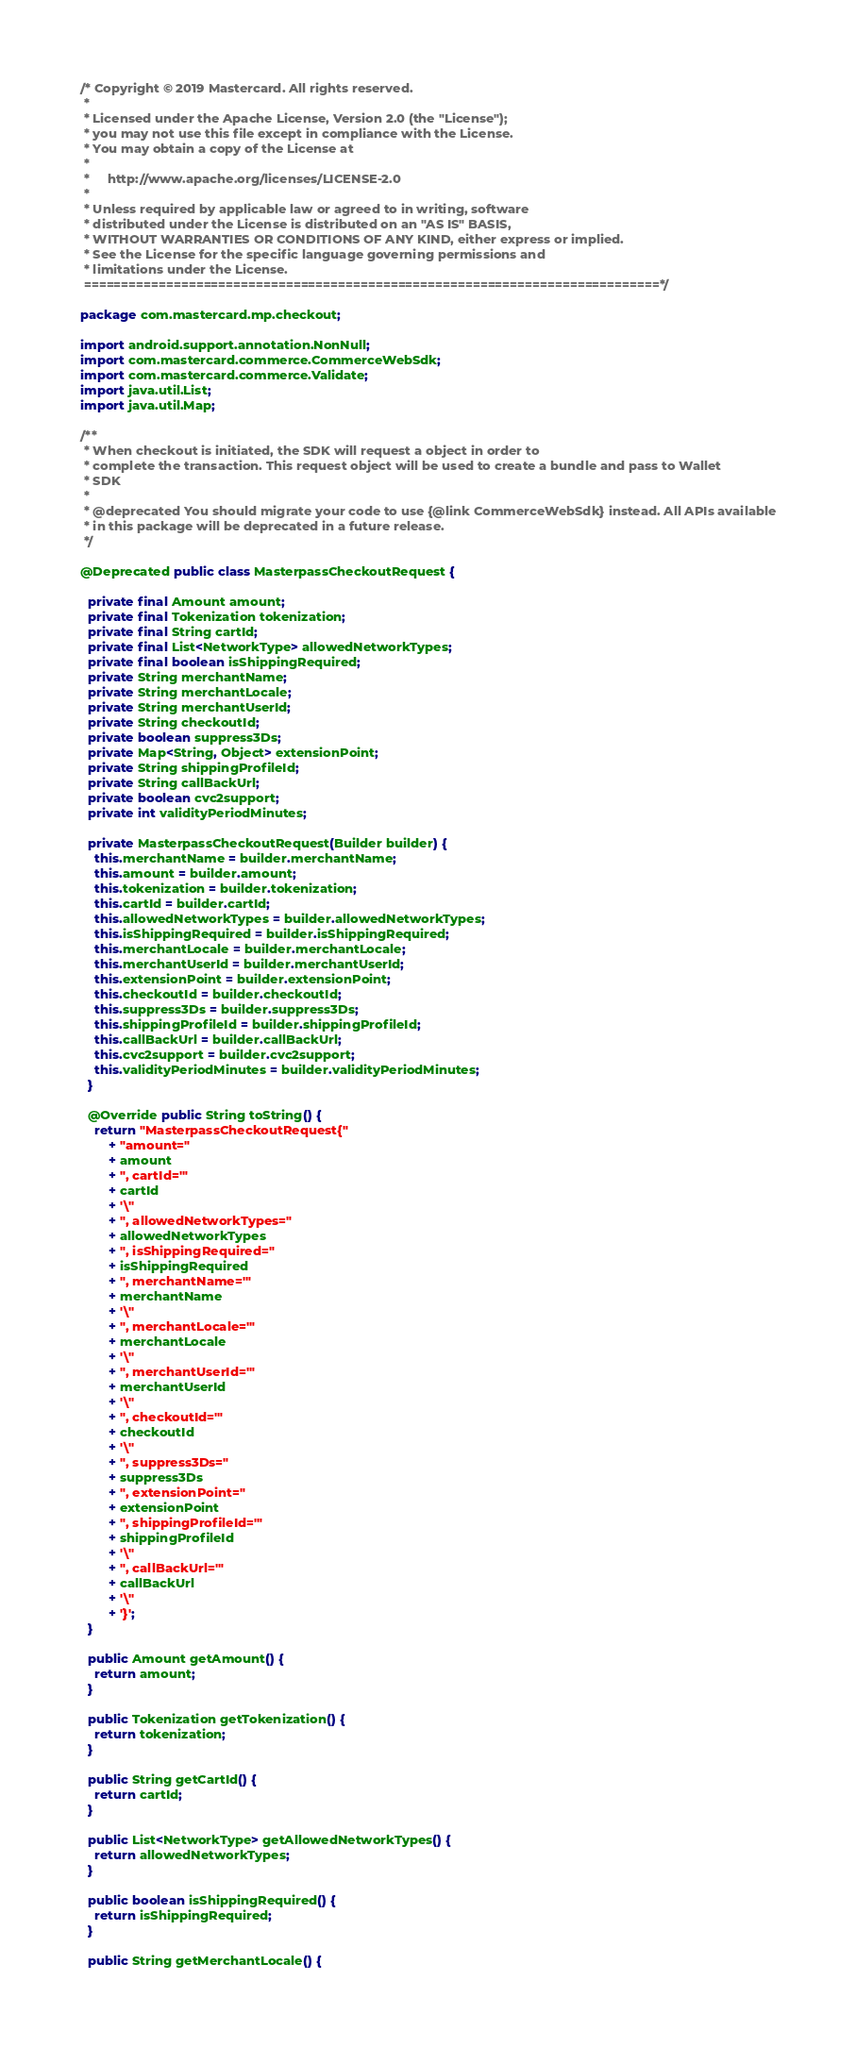<code> <loc_0><loc_0><loc_500><loc_500><_Java_>/* Copyright © 2019 Mastercard. All rights reserved.
 *
 * Licensed under the Apache License, Version 2.0 (the "License");
 * you may not use this file except in compliance with the License.
 * You may obtain a copy of the License at
 *
 *     http://www.apache.org/licenses/LICENSE-2.0
 *
 * Unless required by applicable law or agreed to in writing, software
 * distributed under the License is distributed on an "AS IS" BASIS,
 * WITHOUT WARRANTIES OR CONDITIONS OF ANY KIND, either express or implied.
 * See the License for the specific language governing permissions and
 * limitations under the License.
 =============================================================================*/

package com.mastercard.mp.checkout;

import android.support.annotation.NonNull;
import com.mastercard.commerce.CommerceWebSdk;
import com.mastercard.commerce.Validate;
import java.util.List;
import java.util.Map;

/**
 * When checkout is initiated, the SDK will request a object in order to
 * complete the transaction. This request object will be used to create a bundle and pass to Wallet
 * SDK
 *
 * @deprecated You should migrate your code to use {@link CommerceWebSdk} instead. All APIs available
 * in this package will be deprecated in a future release.
 */

@Deprecated public class MasterpassCheckoutRequest {

  private final Amount amount;
  private final Tokenization tokenization;
  private final String cartId;
  private final List<NetworkType> allowedNetworkTypes;
  private final boolean isShippingRequired;
  private String merchantName;
  private String merchantLocale;
  private String merchantUserId;
  private String checkoutId;
  private boolean suppress3Ds;
  private Map<String, Object> extensionPoint;
  private String shippingProfileId;
  private String callBackUrl;
  private boolean cvc2support;
  private int validityPeriodMinutes;

  private MasterpassCheckoutRequest(Builder builder) {
    this.merchantName = builder.merchantName;
    this.amount = builder.amount;
    this.tokenization = builder.tokenization;
    this.cartId = builder.cartId;
    this.allowedNetworkTypes = builder.allowedNetworkTypes;
    this.isShippingRequired = builder.isShippingRequired;
    this.merchantLocale = builder.merchantLocale;
    this.merchantUserId = builder.merchantUserId;
    this.extensionPoint = builder.extensionPoint;
    this.checkoutId = builder.checkoutId;
    this.suppress3Ds = builder.suppress3Ds;
    this.shippingProfileId = builder.shippingProfileId;
    this.callBackUrl = builder.callBackUrl;
    this.cvc2support = builder.cvc2support;
    this.validityPeriodMinutes = builder.validityPeriodMinutes;
  }

  @Override public String toString() {
    return "MasterpassCheckoutRequest{"
        + "amount="
        + amount
        + ", cartId='"
        + cartId
        + '\''
        + ", allowedNetworkTypes="
        + allowedNetworkTypes
        + ", isShippingRequired="
        + isShippingRequired
        + ", merchantName='"
        + merchantName
        + '\''
        + ", merchantLocale='"
        + merchantLocale
        + '\''
        + ", merchantUserId='"
        + merchantUserId
        + '\''
        + ", checkoutId='"
        + checkoutId
        + '\''
        + ", suppress3Ds="
        + suppress3Ds
        + ", extensionPoint="
        + extensionPoint
        + ", shippingProfileId='"
        + shippingProfileId
        + '\''
        + ", callBackUrl='"
        + callBackUrl
        + '\''
        + '}';
  }

  public Amount getAmount() {
    return amount;
  }

  public Tokenization getTokenization() {
    return tokenization;
  }

  public String getCartId() {
    return cartId;
  }

  public List<NetworkType> getAllowedNetworkTypes() {
    return allowedNetworkTypes;
  }

  public boolean isShippingRequired() {
    return isShippingRequired;
  }

  public String getMerchantLocale() {</code> 